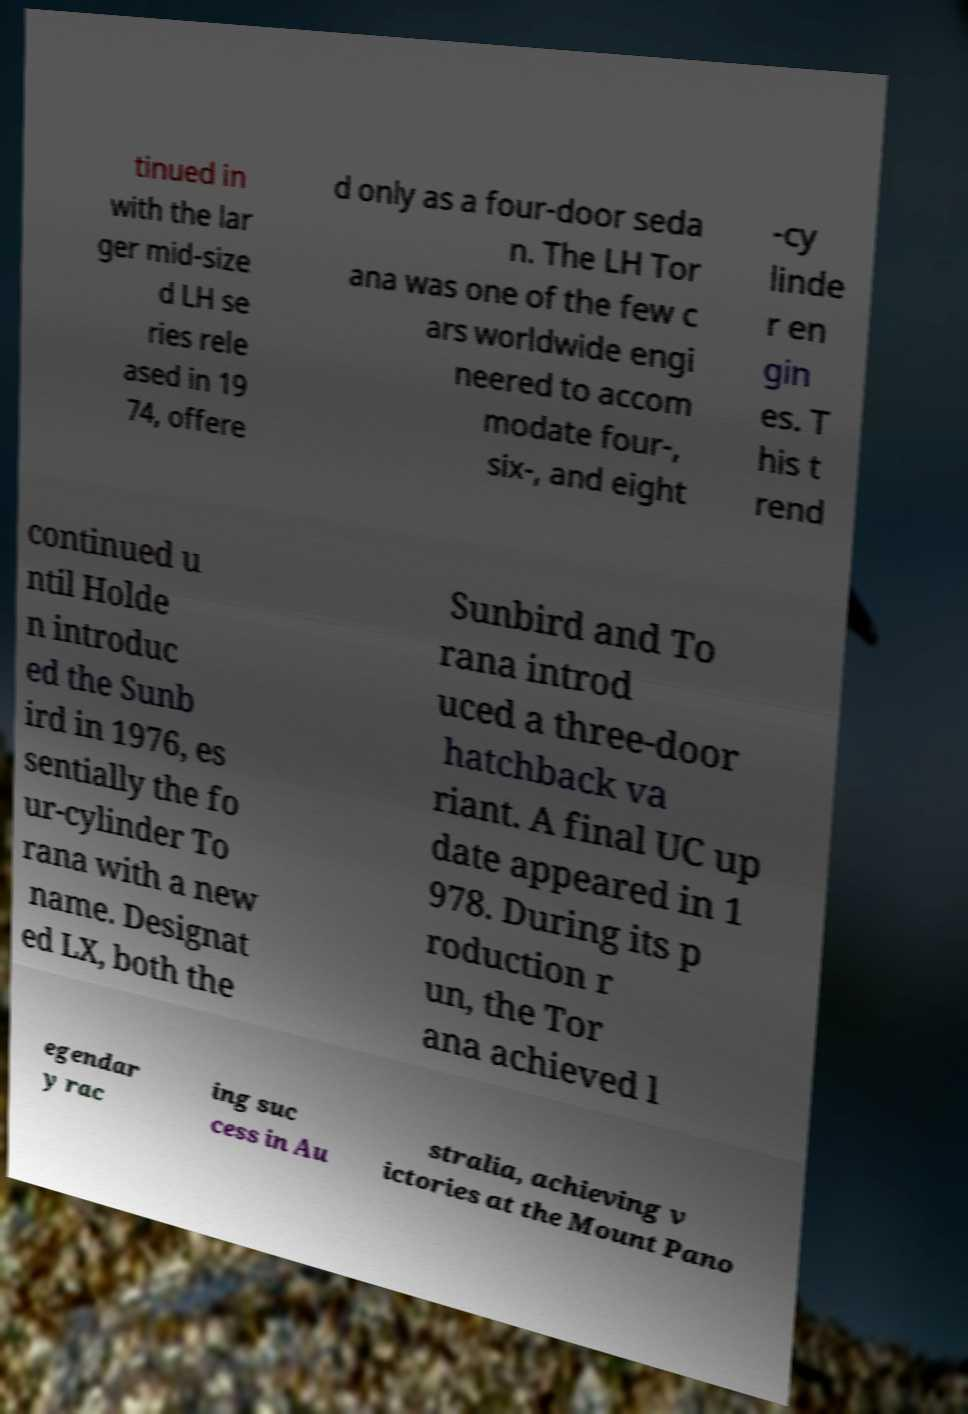For documentation purposes, I need the text within this image transcribed. Could you provide that? tinued in with the lar ger mid-size d LH se ries rele ased in 19 74, offere d only as a four-door seda n. The LH Tor ana was one of the few c ars worldwide engi neered to accom modate four-, six-, and eight -cy linde r en gin es. T his t rend continued u ntil Holde n introduc ed the Sunb ird in 1976, es sentially the fo ur-cylinder To rana with a new name. Designat ed LX, both the Sunbird and To rana introd uced a three-door hatchback va riant. A final UC up date appeared in 1 978. During its p roduction r un, the Tor ana achieved l egendar y rac ing suc cess in Au stralia, achieving v ictories at the Mount Pano 